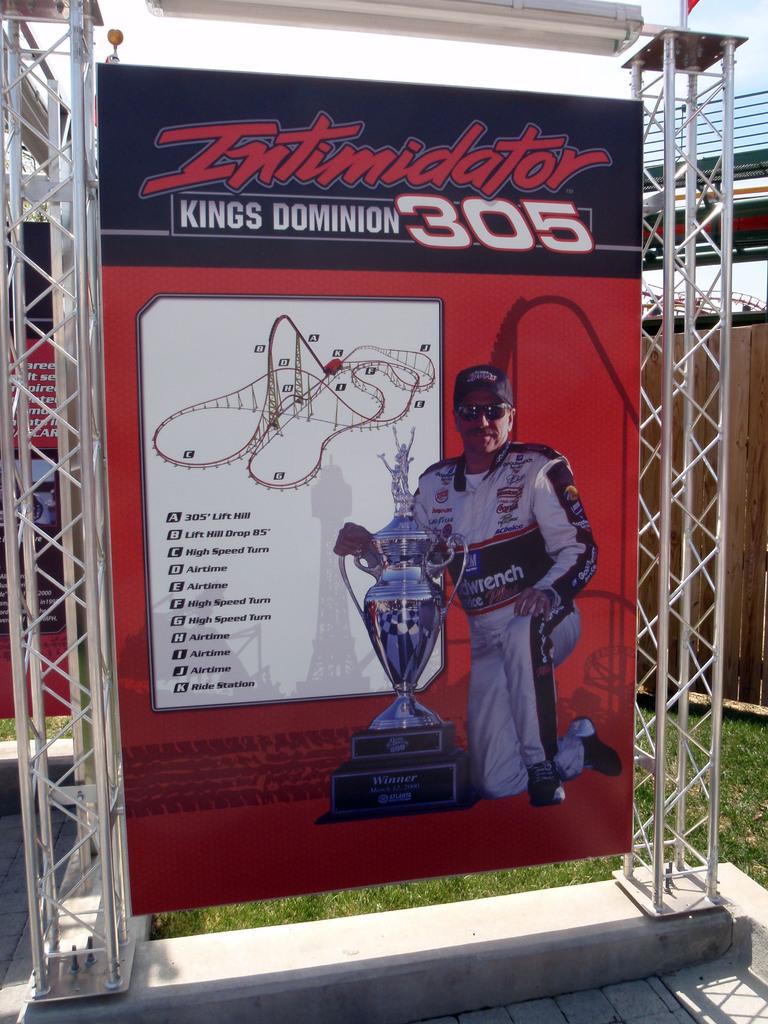What numbers are on the sign in white?
Provide a succinct answer. 305. 